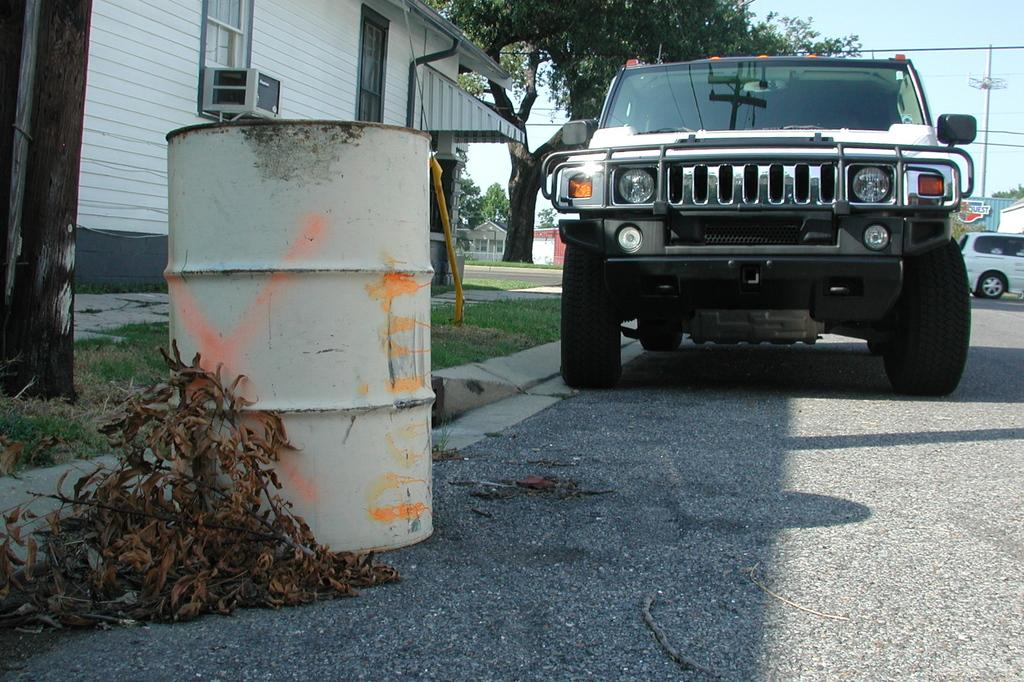What type of vehicle is in the image? There is a car in the image. What else can be seen in the image besides the car? There is a water container, dried leaves on the road, a building, trees, a pole, and the sky visible in the image. Can you describe the water container in the image? The water container is present in the image, but its specific features are not mentioned in the provided facts. What type of structure is visible in the image? There is a building in the image. What natural elements can be seen in the image? Trees are visible in the image. What type of paper is being used to solve the riddle in the image? There is no paper or riddle present in the image. What type of pest can be seen crawling on the car in the image? There is no pest visible on the car in the image. 